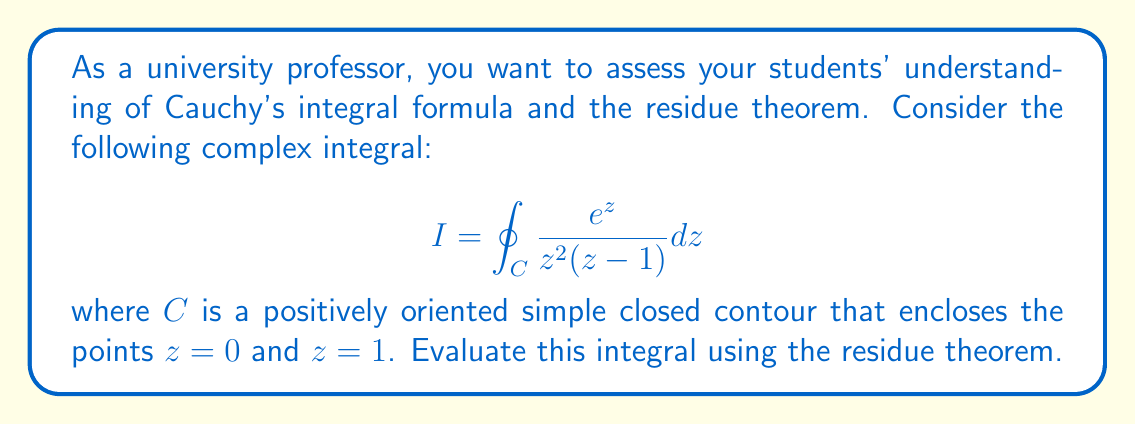Can you answer this question? To evaluate this integral using the residue theorem, we follow these steps:

1) The residue theorem states that for a function $f(z)$ that is analytic inside and on a simple closed contour $C$, except for a finite number of singular points $z_1, z_2, ..., z_n$ inside $C$:

   $$\oint_C f(z) dz = 2\pi i \sum_{k=1}^n \text{Res}[f(z), z_k]$$

2) In our case, $f(z) = \frac{e^z}{z^2(z-1)}$. We have singularities at $z=0$ (a pole of order 2) and $z=1$ (a simple pole).

3) Let's calculate the residues:

   a) At $z=0$ (pole of order 2):
      $$\text{Res}[f(z), 0] = \lim_{z \to 0} \frac{d}{dz} \left[z^2 \cdot \frac{e^z}{z^2(z-1)}\right]$$
      $$= \lim_{z \to 0} \frac{d}{dz} \left[\frac{e^z}{z-1}\right]$$
      $$= \lim_{z \to 0} \frac{e^z(z-1) - e^z(-1)}{(z-1)^2}$$
      $$= \lim_{z \to 0} \frac{e^z z}{(z-1)^2} = -1$$

   b) At $z=1$ (simple pole):
      $$\text{Res}[f(z), 1] = \lim_{z \to 1} (z-1) \cdot \frac{e^z}{z^2(z-1)} = \frac{e}{1^2} = e$$

4) Applying the residue theorem:

   $$I = 2\pi i (\text{Res}[f(z), 0] + \text{Res}[f(z), 1])$$
   $$= 2\pi i (-1 + e)$$
   $$= 2\pi i (e - 1)$$

Thus, we have evaluated the integral using the residue theorem.
Answer: $$I = 2\pi i (e - 1)$$ 